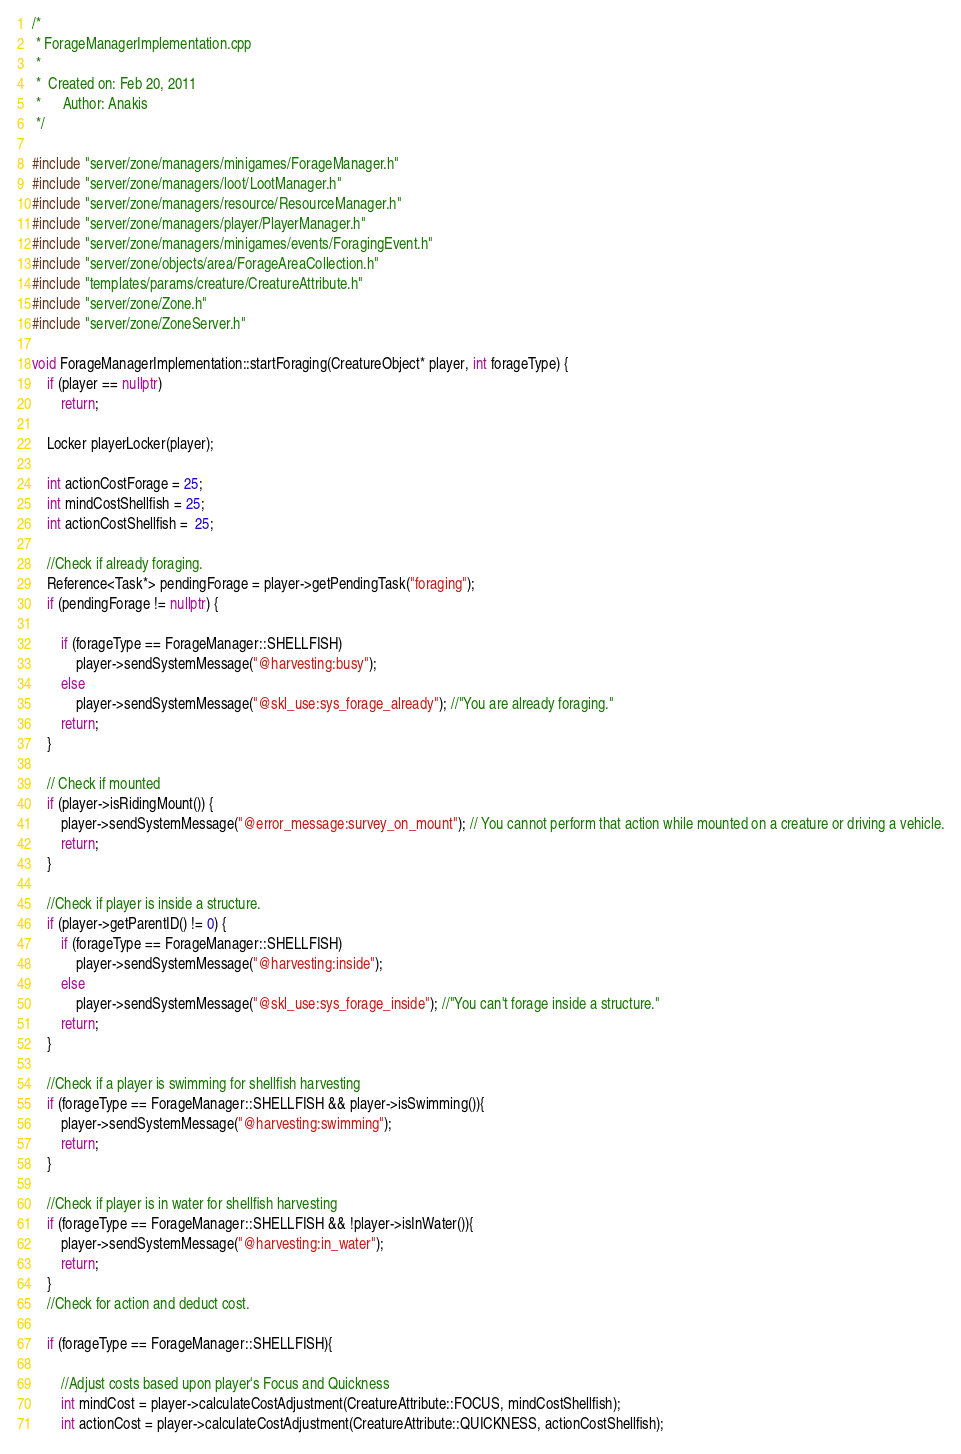Convert code to text. <code><loc_0><loc_0><loc_500><loc_500><_C++_>/*
 * ForageManagerImplementation.cpp
 *
 *  Created on: Feb 20, 2011
 *      Author: Anakis
 */

#include "server/zone/managers/minigames/ForageManager.h"
#include "server/zone/managers/loot/LootManager.h"
#include "server/zone/managers/resource/ResourceManager.h"
#include "server/zone/managers/player/PlayerManager.h"
#include "server/zone/managers/minigames/events/ForagingEvent.h"
#include "server/zone/objects/area/ForageAreaCollection.h"
#include "templates/params/creature/CreatureAttribute.h"
#include "server/zone/Zone.h"
#include "server/zone/ZoneServer.h"

void ForageManagerImplementation::startForaging(CreatureObject* player, int forageType) {
	if (player == nullptr)
		return;

	Locker playerLocker(player);

	int actionCostForage = 25;
	int mindCostShellfish = 25;
	int actionCostShellfish =  25;

	//Check if already foraging.
	Reference<Task*> pendingForage = player->getPendingTask("foraging");
	if (pendingForage != nullptr) {

		if (forageType == ForageManager::SHELLFISH)
			player->sendSystemMessage("@harvesting:busy");
		else
			player->sendSystemMessage("@skl_use:sys_forage_already"); //"You are already foraging."
		return;
	}

	// Check if mounted
	if (player->isRidingMount()) {
		player->sendSystemMessage("@error_message:survey_on_mount"); // You cannot perform that action while mounted on a creature or driving a vehicle.
		return;
	}

	//Check if player is inside a structure.
	if (player->getParentID() != 0) {
		if (forageType == ForageManager::SHELLFISH)
			player->sendSystemMessage("@harvesting:inside");
		else
			player->sendSystemMessage("@skl_use:sys_forage_inside"); //"You can't forage inside a structure."
		return;
	}

	//Check if a player is swimming for shellfish harvesting
	if (forageType == ForageManager::SHELLFISH && player->isSwimming()){
		player->sendSystemMessage("@harvesting:swimming");
		return;
	}

	//Check if player is in water for shellfish harvesting
	if (forageType == ForageManager::SHELLFISH && !player->isInWater()){
		player->sendSystemMessage("@harvesting:in_water");
		return;
	}
    //Check for action and deduct cost.

	if (forageType == ForageManager::SHELLFISH){

		//Adjust costs based upon player's Focus and Quickness
		int mindCost = player->calculateCostAdjustment(CreatureAttribute::FOCUS, mindCostShellfish);
		int actionCost = player->calculateCostAdjustment(CreatureAttribute::QUICKNESS, actionCostShellfish);
</code> 